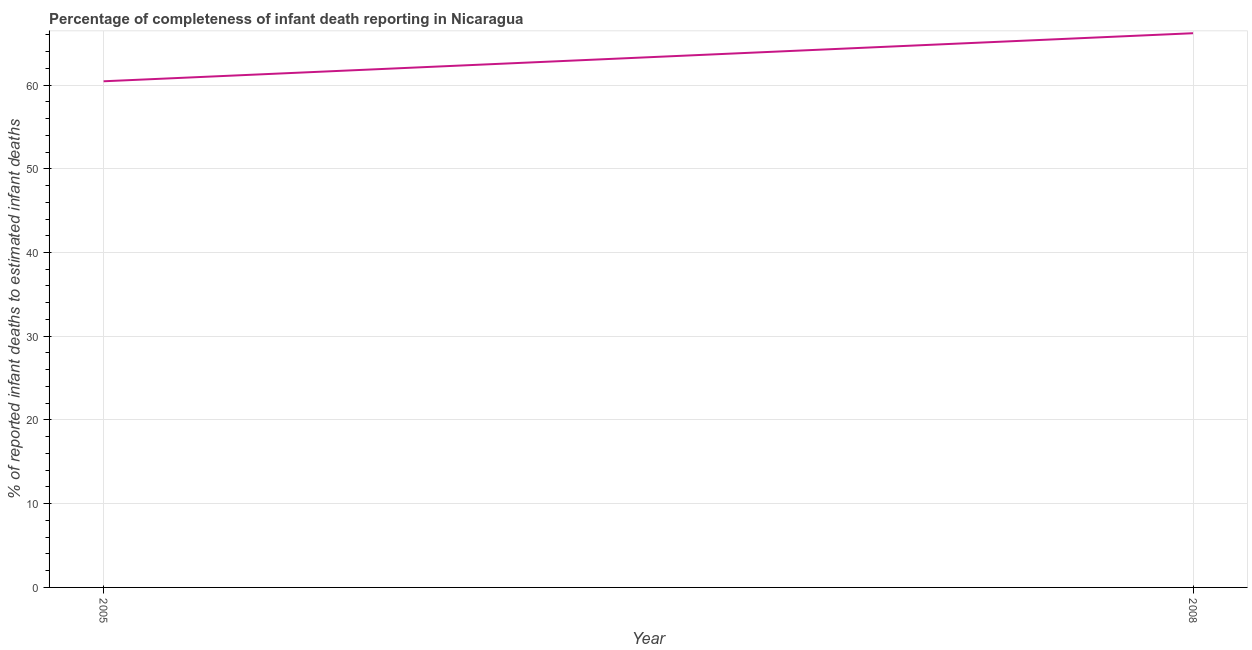What is the completeness of infant death reporting in 2005?
Give a very brief answer. 60.45. Across all years, what is the maximum completeness of infant death reporting?
Your response must be concise. 66.19. Across all years, what is the minimum completeness of infant death reporting?
Offer a terse response. 60.45. In which year was the completeness of infant death reporting maximum?
Your answer should be very brief. 2008. What is the sum of the completeness of infant death reporting?
Offer a very short reply. 126.64. What is the difference between the completeness of infant death reporting in 2005 and 2008?
Your answer should be compact. -5.74. What is the average completeness of infant death reporting per year?
Ensure brevity in your answer.  63.32. What is the median completeness of infant death reporting?
Provide a succinct answer. 63.32. What is the ratio of the completeness of infant death reporting in 2005 to that in 2008?
Give a very brief answer. 0.91. Is the completeness of infant death reporting in 2005 less than that in 2008?
Offer a terse response. Yes. Does the completeness of infant death reporting monotonically increase over the years?
Your answer should be compact. Yes. How many lines are there?
Your response must be concise. 1. What is the title of the graph?
Your answer should be compact. Percentage of completeness of infant death reporting in Nicaragua. What is the label or title of the Y-axis?
Ensure brevity in your answer.  % of reported infant deaths to estimated infant deaths. What is the % of reported infant deaths to estimated infant deaths of 2005?
Offer a terse response. 60.45. What is the % of reported infant deaths to estimated infant deaths of 2008?
Ensure brevity in your answer.  66.19. What is the difference between the % of reported infant deaths to estimated infant deaths in 2005 and 2008?
Ensure brevity in your answer.  -5.74. 